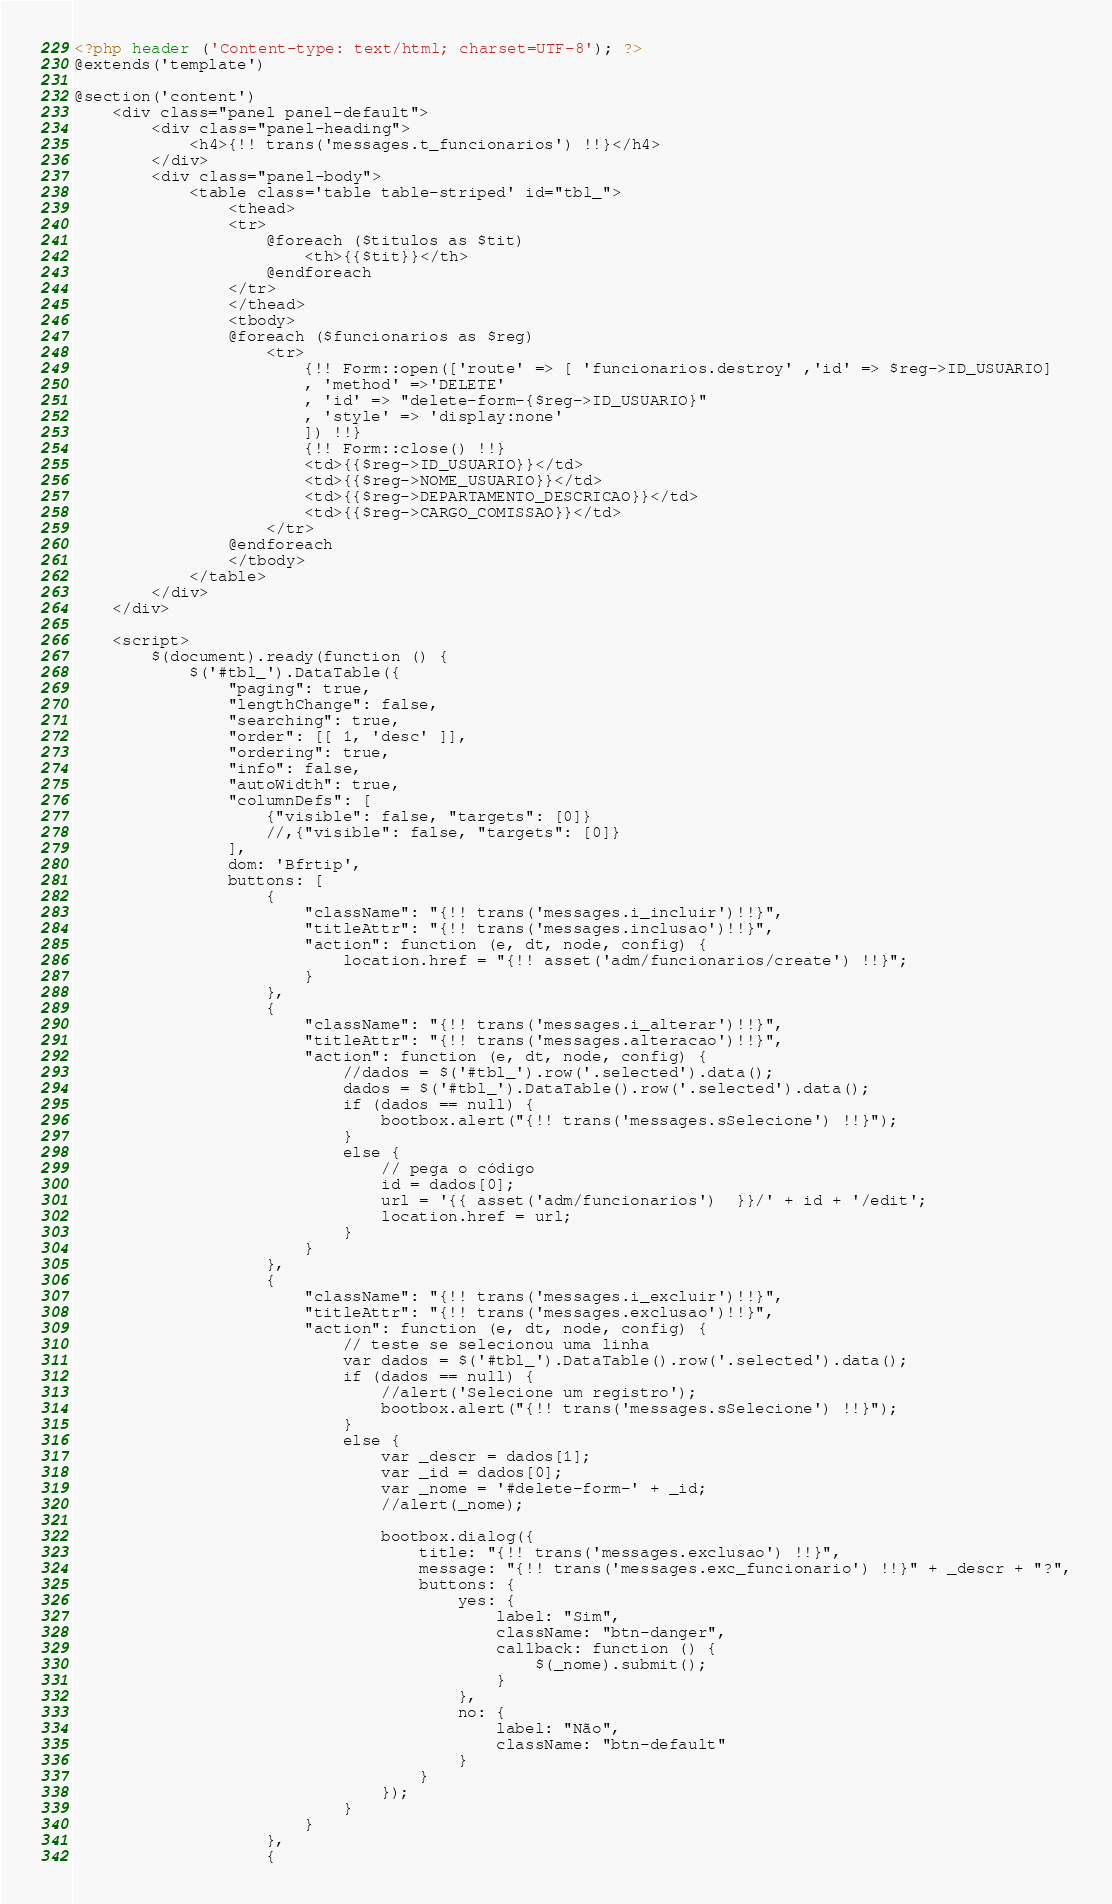<code> <loc_0><loc_0><loc_500><loc_500><_PHP_><?php header ('Content-type: text/html; charset=UTF-8'); ?>
@extends('template')

@section('content')
    <div class="panel panel-default">
        <div class="panel-heading">
            <h4>{!! trans('messages.t_funcionarios') !!}</h4>
        </div>
        <div class="panel-body">
            <table class='table table-striped' id="tbl_">
                <thead>
                <tr>
                    @foreach ($titulos as $tit)
                        <th>{{$tit}}</th>
                    @endforeach
                </tr>
                </thead>
                <tbody>
                @foreach ($funcionarios as $reg)
                    <tr>
                        {!! Form::open(['route' => [ 'funcionarios.destroy' ,'id' => $reg->ID_USUARIO]
                        , 'method' =>'DELETE'
                        , 'id' => "delete-form-{$reg->ID_USUARIO}"
                        , 'style' => 'display:none'
                        ]) !!}
                        {!! Form::close() !!}
                        <td>{{$reg->ID_USUARIO}}</td>
                        <td>{{$reg->NOME_USUARIO}}</td>
                        <td>{{$reg->DEPARTAMENTO_DESCRICAO}}</td>
                        <td>{{$reg->CARGO_COMISSAO}}</td>
                    </tr>
                @endforeach
                </tbody>
            </table>
        </div>
    </div>

    <script>
        $(document).ready(function () {
            $('#tbl_').DataTable({
                "paging": true,
                "lengthChange": false,
                "searching": true,
                "order": [[ 1, 'desc' ]],
                "ordering": true,
                "info": false,
                "autoWidth": true,
                "columnDefs": [
                    {"visible": false, "targets": [0]}
                    //,{"visible": false, "targets": [0]}
                ],
                dom: 'Bfrtip',
                buttons: [
                    {
                        "className": "{!! trans('messages.i_incluir')!!}",
                        "titleAttr": "{!! trans('messages.inclusao')!!}",
                        "action": function (e, dt, node, config) {
                            location.href = "{!! asset('adm/funcionarios/create') !!}";
                        }
                    },
                    {
                        "className": "{!! trans('messages.i_alterar')!!}",
                        "titleAttr": "{!! trans('messages.alteracao')!!}",
                        "action": function (e, dt, node, config) {
                            //dados = $('#tbl_').row('.selected').data();
                            dados = $('#tbl_').DataTable().row('.selected').data();
                            if (dados == null) {
                                bootbox.alert("{!! trans('messages.sSelecione') !!}");
                            }
                            else {
                                // pega o código
                                id = dados[0];
                                url = '{{ asset('adm/funcionarios')  }}/' + id + '/edit';
                                location.href = url;
                            }
                        }
                    },
                    {
                        "className": "{!! trans('messages.i_excluir')!!}",
                        "titleAttr": "{!! trans('messages.exclusao')!!}",
                        "action": function (e, dt, node, config) {
                            // teste se selecionou uma linha
                            var dados = $('#tbl_').DataTable().row('.selected').data();
                            if (dados == null) {
                                //alert('Selecione um registro');
                                bootbox.alert("{!! trans('messages.sSelecione') !!}");
                            }
                            else {
                                var _descr = dados[1];
                                var _id = dados[0];
                                var _nome = '#delete-form-' + _id;
                                //alert(_nome);

                                bootbox.dialog({
                                    title: "{!! trans('messages.exclusao') !!}",
                                    message: "{!! trans('messages.exc_funcionario') !!}" + _descr + "?",
                                    buttons: {
                                        yes: {
                                            label: "Sim",
                                            className: "btn-danger",
                                            callback: function () {
                                                $(_nome).submit();
                                            }
                                        },
                                        no: {
                                            label: "Não",
                                            className: "btn-default"
                                        }
                                    }
                                });
                            }
                        }
                    },
                    {</code> 